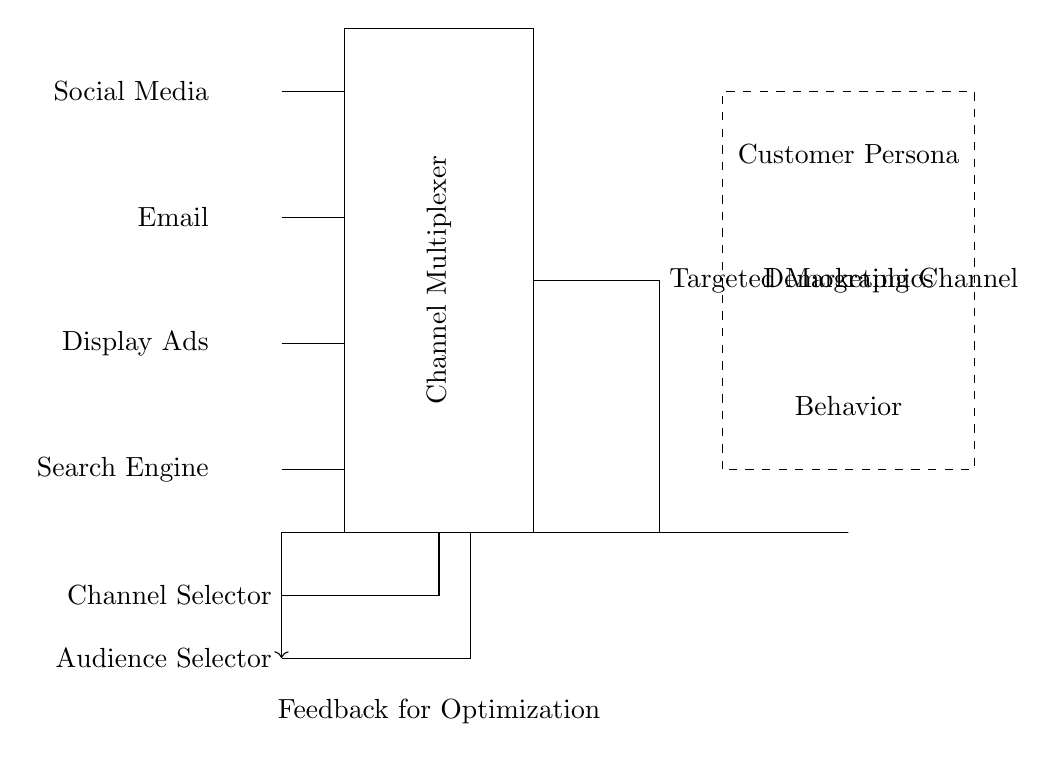What is the type of circuit depicted? The circuit is a multiplexer circuit, identified by the rectangle labeled "Channel Multiplexer" in the diagram.
Answer: multiplexer How many input channels are there? There are four input channels labeled as Social Media, Email, Display Ads, and Search Engine, indicated by the four lines coming into the multiplexer.
Answer: four What kind of feedback is shown in the circuit? The circuit illustrates a "Feedback for Optimization" loop that connects the output from the targeted marketing channel back to the audience selector, showing a process of continual improvement.
Answer: Feedback for Optimization What is the purpose of the multiplexer? The multiplexer is designed to select one of the four input channels based on the channel and audience selector inputs, directing the chosen channel to the targeted marketing channel output.
Answer: select marketing channel What is indicated by the dashed rectangle in the circuit? The dashed rectangle represents the Customer Persona block, detailing the demographic and behavioral characteristics that influence the marketing decision-making process.
Answer: Customer Persona Which elements are required for the multiplexer to function? The multiplexer requires both channel and audience selectors as inputs to determine which marketing channel is activated, as shown by the lines entering the multiplexer from below.
Answer: channel and audience selectors What does the arrow from the output signify? The arrow signifies feedback that is critical for optimization, demonstrating how the effectiveness of the targeted marketing channel influences future selections in the audience selector.
Answer: Feedback for Optimization 